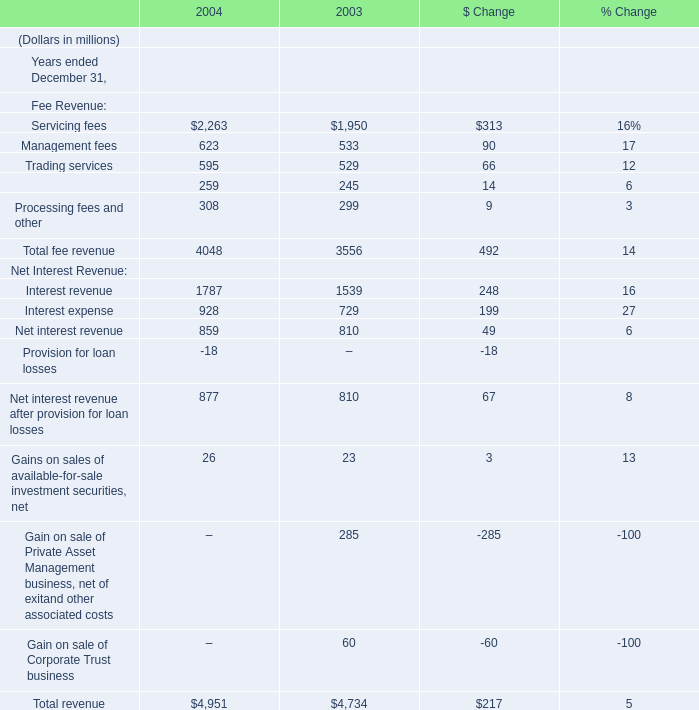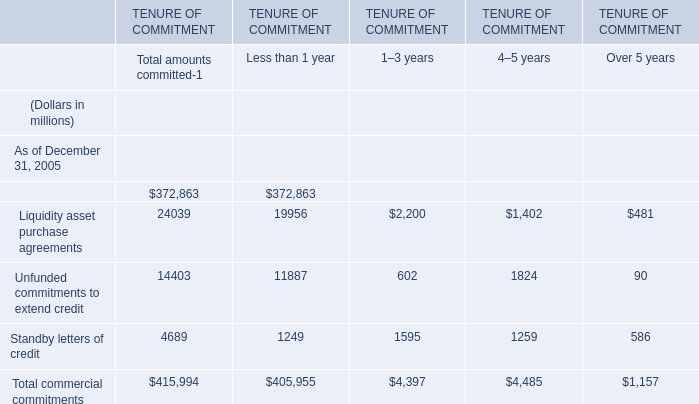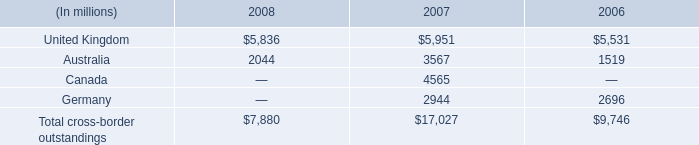What is the average amount of Servicing fees of 2003, and Liquidity asset purchase agreements of TENURE OF COMMITMENT 1–3 years ? 
Computations: ((1950.0 + 2200.0) / 2)
Answer: 2075.0. 